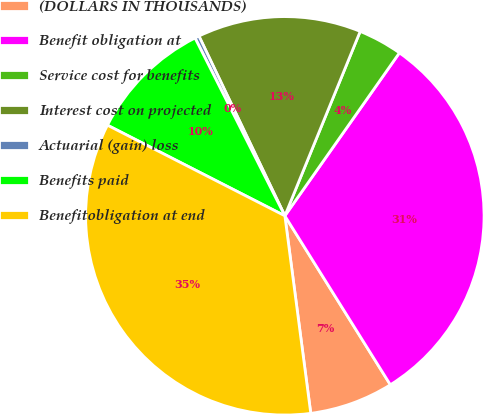Convert chart to OTSL. <chart><loc_0><loc_0><loc_500><loc_500><pie_chart><fcel>(DOLLARS IN THOUSANDS)<fcel>Benefit obligation at<fcel>Service cost for benefits<fcel>Interest cost on projected<fcel>Actuarial (gain) loss<fcel>Benefits paid<fcel>Benefitobligation at end<nl><fcel>6.81%<fcel>31.37%<fcel>3.58%<fcel>13.27%<fcel>0.35%<fcel>10.04%<fcel>34.6%<nl></chart> 